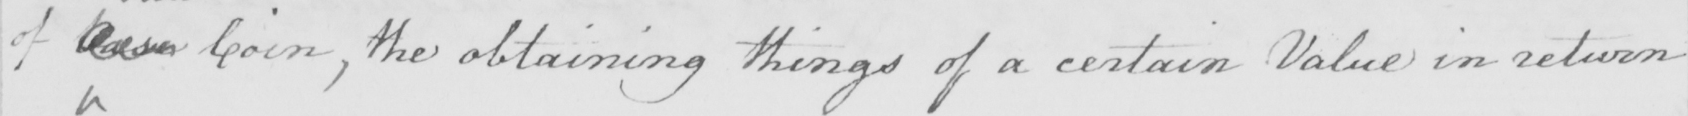Please provide the text content of this handwritten line. of base Coin , the obtaining things of a certain Value in return 